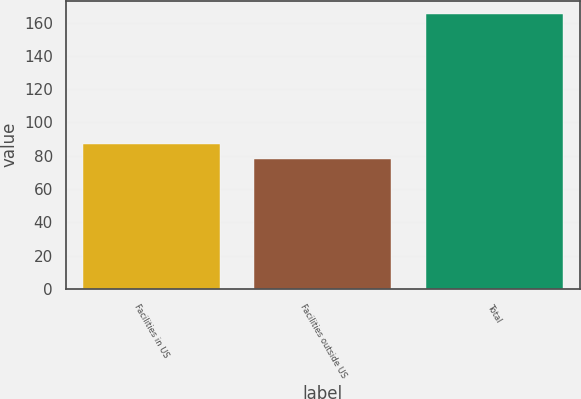Convert chart to OTSL. <chart><loc_0><loc_0><loc_500><loc_500><bar_chart><fcel>Facilities in US<fcel>Facilities outside US<fcel>Total<nl><fcel>87<fcel>78<fcel>165<nl></chart> 